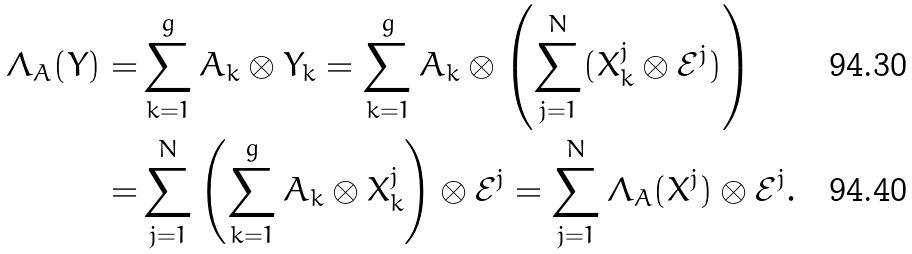Convert formula to latex. <formula><loc_0><loc_0><loc_500><loc_500>\Lambda _ { A } ( Y ) = & \sum _ { k = 1 } ^ { g } A _ { k } \otimes Y _ { k } = \sum _ { k = 1 } ^ { g } A _ { k } \otimes \left ( \sum _ { j = 1 } ^ { N } ( X ^ { j } _ { k } \otimes \mathcal { E } ^ { j } ) \right ) \\ = & \sum _ { j = 1 } ^ { N } \left ( \sum _ { k = 1 } ^ { g } A _ { k } \otimes X ^ { j } _ { k } \right ) \otimes \mathcal { E } ^ { j } = \sum _ { j = 1 } ^ { N } \Lambda _ { A } ( X ^ { j } ) \otimes \mathcal { E } ^ { j } .</formula> 